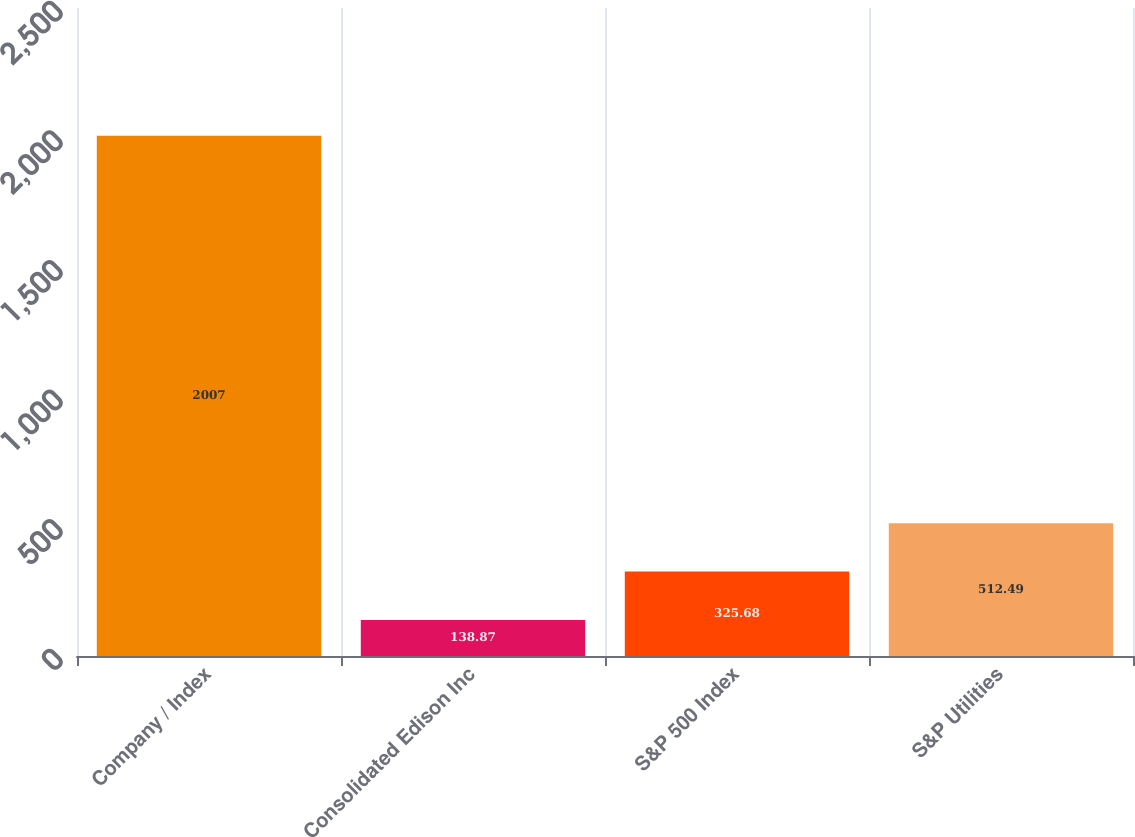Convert chart to OTSL. <chart><loc_0><loc_0><loc_500><loc_500><bar_chart><fcel>Company / Index<fcel>Consolidated Edison Inc<fcel>S&P 500 Index<fcel>S&P Utilities<nl><fcel>2007<fcel>138.87<fcel>325.68<fcel>512.49<nl></chart> 